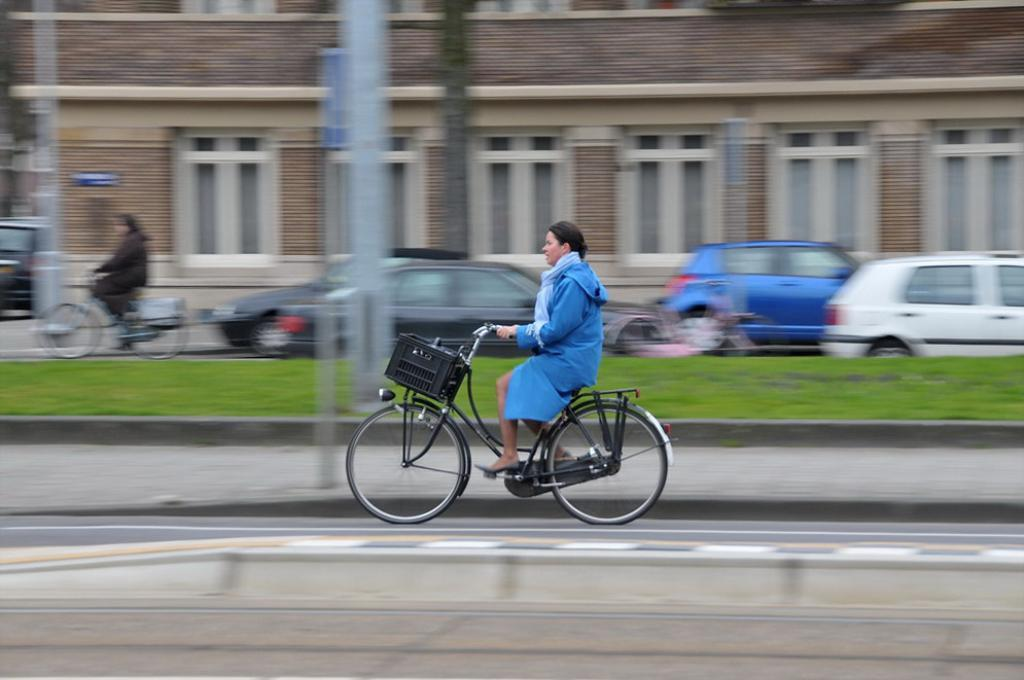How many people are in the image? There are two persons in the image. What are the persons doing in the image? The persons are riding bicycles. Where are the bicycles located? The bicycles are on a road. What can be seen in the image besides the bicycles and persons? There is grass, poles, cars, and a building visible in the image. What type of birds can be seen flying over the building in the image? There are no birds visible in the image; it only features two persons riding bicycles, a road, grass, poles, cars, and a building. 